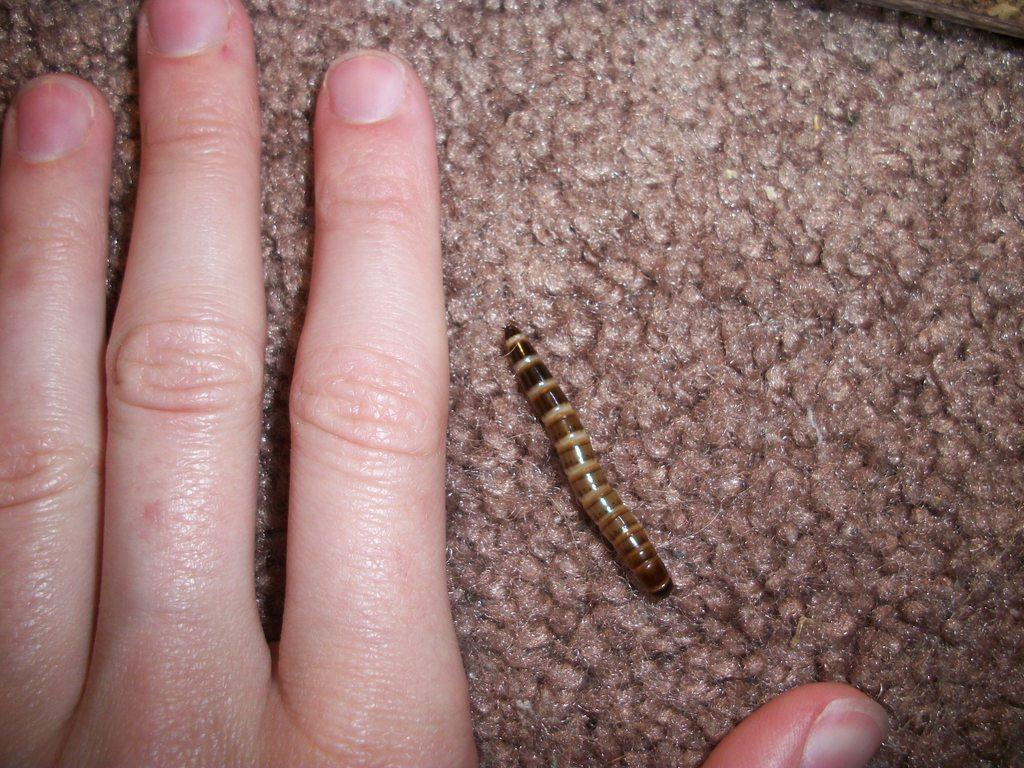What part of the human body is visible in the image? There is a human hand in the image. What type of creature is also present in the image? There is a worm in the image. On what surface is the worm placed? The worm is placed on a surface. What industry is represented by the worm in the image? There is no industry represented by the worm in the image; it is simply a worm placed on a surface. 